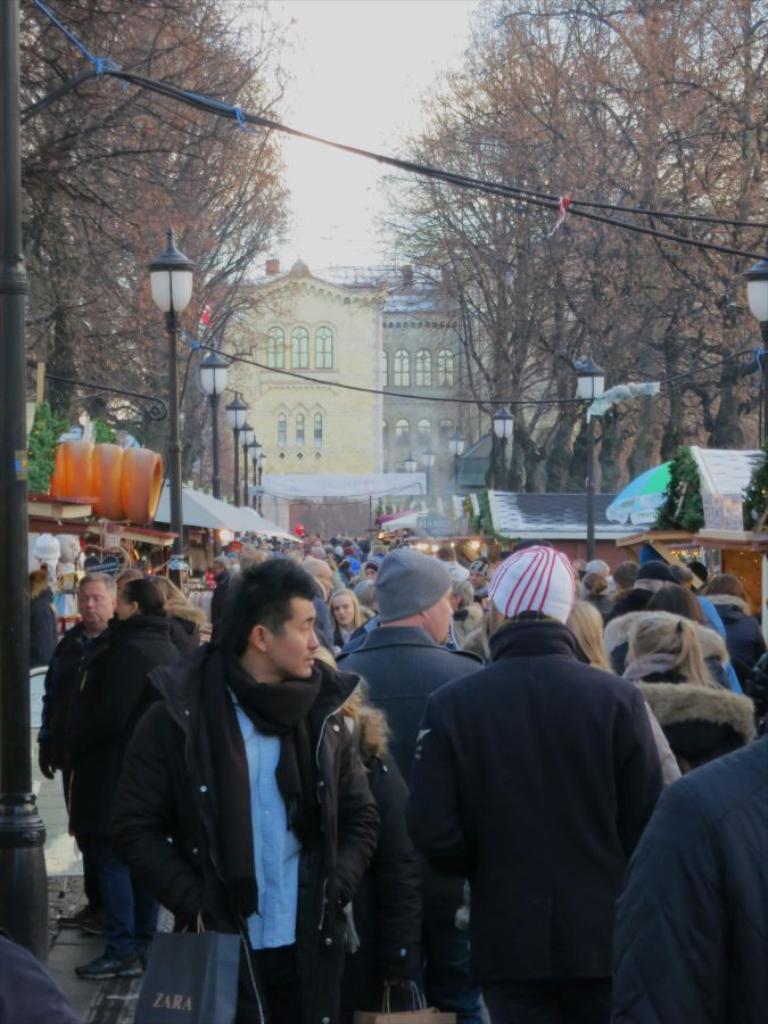Please provide a concise description of this image. In the picture we can see a street and a number of public in the street and on the other sides of the path we can see shops and trees which are dried and in the background we can see a building with windows and sky behind it. 